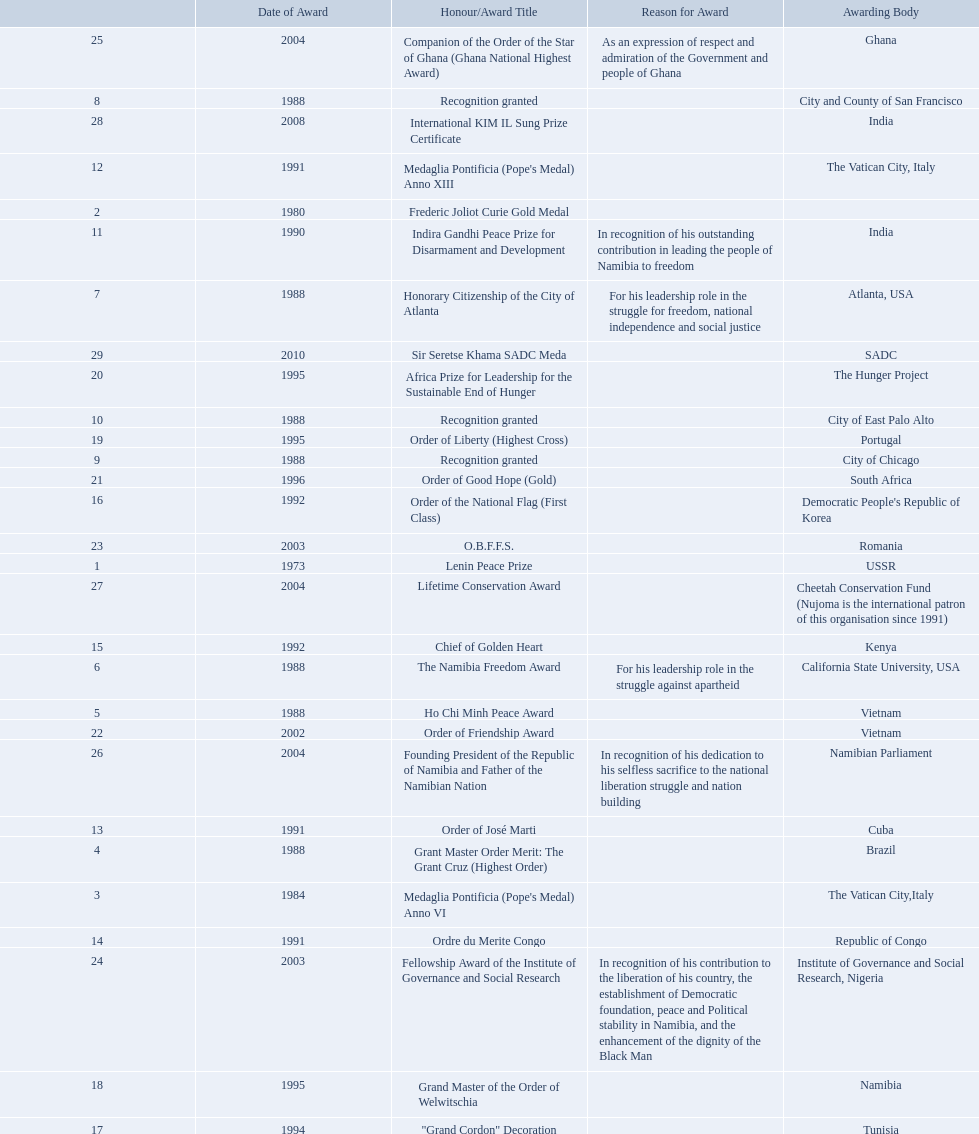What awards did sam nujoma win? 1, 1973, Lenin Peace Prize, Frederic Joliot Curie Gold Medal, Medaglia Pontificia (Pope's Medal) Anno VI, Grant Master Order Merit: The Grant Cruz (Highest Order), Ho Chi Minh Peace Award, The Namibia Freedom Award, Honorary Citizenship of the City of Atlanta, Recognition granted, Recognition granted, Recognition granted, Indira Gandhi Peace Prize for Disarmament and Development, Medaglia Pontificia (Pope's Medal) Anno XIII, Order of José Marti, Ordre du Merite Congo, Chief of Golden Heart, Order of the National Flag (First Class), "Grand Cordon" Decoration, Grand Master of the Order of Welwitschia, Order of Liberty (Highest Cross), Africa Prize for Leadership for the Sustainable End of Hunger, Order of Good Hope (Gold), Order of Friendship Award, O.B.F.F.S., Fellowship Award of the Institute of Governance and Social Research, Companion of the Order of the Star of Ghana (Ghana National Highest Award), Founding President of the Republic of Namibia and Father of the Namibian Nation, Lifetime Conservation Award, International KIM IL Sung Prize Certificate, Sir Seretse Khama SADC Meda. Who was the awarding body for the o.b.f.f.s award? Romania. 